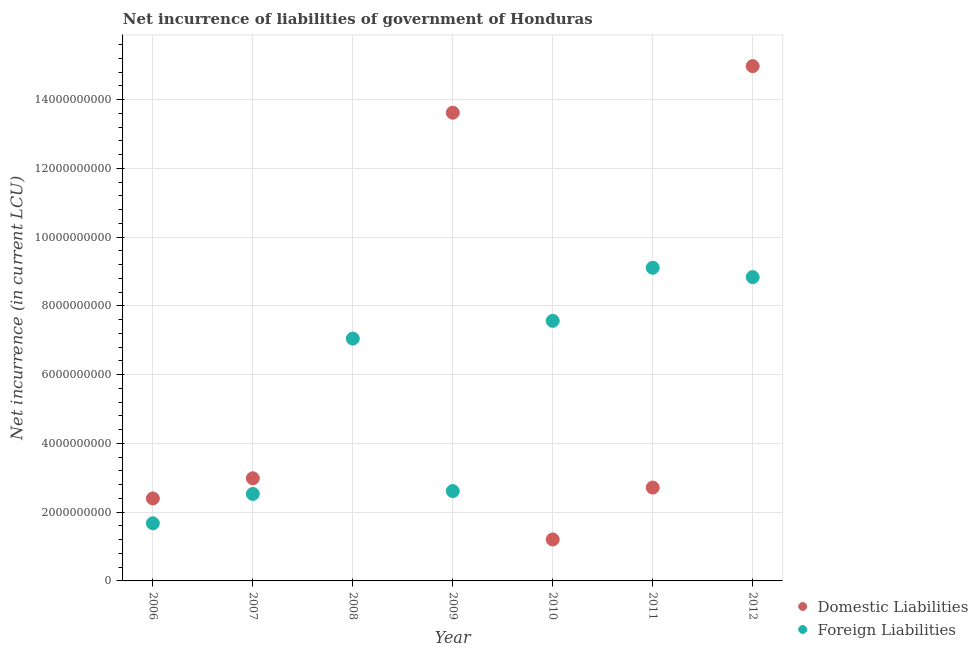How many different coloured dotlines are there?
Your answer should be compact. 2. What is the net incurrence of foreign liabilities in 2007?
Ensure brevity in your answer.  2.53e+09. Across all years, what is the maximum net incurrence of foreign liabilities?
Offer a terse response. 9.11e+09. In which year was the net incurrence of foreign liabilities maximum?
Your response must be concise. 2011. What is the total net incurrence of domestic liabilities in the graph?
Your answer should be compact. 3.79e+1. What is the difference between the net incurrence of foreign liabilities in 2006 and that in 2009?
Your answer should be very brief. -9.38e+08. What is the difference between the net incurrence of foreign liabilities in 2011 and the net incurrence of domestic liabilities in 2007?
Your answer should be compact. 6.12e+09. What is the average net incurrence of foreign liabilities per year?
Provide a short and direct response. 5.63e+09. In the year 2012, what is the difference between the net incurrence of foreign liabilities and net incurrence of domestic liabilities?
Provide a short and direct response. -6.14e+09. What is the ratio of the net incurrence of foreign liabilities in 2007 to that in 2010?
Give a very brief answer. 0.33. Is the net incurrence of domestic liabilities in 2010 less than that in 2011?
Ensure brevity in your answer.  Yes. Is the difference between the net incurrence of domestic liabilities in 2009 and 2012 greater than the difference between the net incurrence of foreign liabilities in 2009 and 2012?
Give a very brief answer. Yes. What is the difference between the highest and the second highest net incurrence of domestic liabilities?
Your answer should be very brief. 1.36e+09. What is the difference between the highest and the lowest net incurrence of foreign liabilities?
Your answer should be very brief. 7.43e+09. Is the sum of the net incurrence of foreign liabilities in 2007 and 2008 greater than the maximum net incurrence of domestic liabilities across all years?
Keep it short and to the point. No. Does the net incurrence of domestic liabilities monotonically increase over the years?
Offer a terse response. No. How many dotlines are there?
Provide a short and direct response. 2. How many years are there in the graph?
Offer a very short reply. 7. What is the difference between two consecutive major ticks on the Y-axis?
Your answer should be very brief. 2.00e+09. Are the values on the major ticks of Y-axis written in scientific E-notation?
Offer a very short reply. No. Does the graph contain grids?
Offer a terse response. Yes. How many legend labels are there?
Give a very brief answer. 2. What is the title of the graph?
Provide a short and direct response. Net incurrence of liabilities of government of Honduras. What is the label or title of the X-axis?
Keep it short and to the point. Year. What is the label or title of the Y-axis?
Provide a succinct answer. Net incurrence (in current LCU). What is the Net incurrence (in current LCU) in Domestic Liabilities in 2006?
Provide a succinct answer. 2.40e+09. What is the Net incurrence (in current LCU) of Foreign Liabilities in 2006?
Give a very brief answer. 1.68e+09. What is the Net incurrence (in current LCU) in Domestic Liabilities in 2007?
Provide a short and direct response. 2.99e+09. What is the Net incurrence (in current LCU) in Foreign Liabilities in 2007?
Offer a very short reply. 2.53e+09. What is the Net incurrence (in current LCU) in Foreign Liabilities in 2008?
Provide a short and direct response. 7.05e+09. What is the Net incurrence (in current LCU) in Domestic Liabilities in 2009?
Provide a short and direct response. 1.36e+1. What is the Net incurrence (in current LCU) of Foreign Liabilities in 2009?
Provide a succinct answer. 2.61e+09. What is the Net incurrence (in current LCU) in Domestic Liabilities in 2010?
Make the answer very short. 1.21e+09. What is the Net incurrence (in current LCU) in Foreign Liabilities in 2010?
Provide a short and direct response. 7.57e+09. What is the Net incurrence (in current LCU) in Domestic Liabilities in 2011?
Provide a short and direct response. 2.72e+09. What is the Net incurrence (in current LCU) in Foreign Liabilities in 2011?
Your response must be concise. 9.11e+09. What is the Net incurrence (in current LCU) in Domestic Liabilities in 2012?
Offer a very short reply. 1.50e+1. What is the Net incurrence (in current LCU) in Foreign Liabilities in 2012?
Your answer should be compact. 8.84e+09. Across all years, what is the maximum Net incurrence (in current LCU) of Domestic Liabilities?
Offer a terse response. 1.50e+1. Across all years, what is the maximum Net incurrence (in current LCU) of Foreign Liabilities?
Your answer should be very brief. 9.11e+09. Across all years, what is the minimum Net incurrence (in current LCU) of Domestic Liabilities?
Offer a very short reply. 0. Across all years, what is the minimum Net incurrence (in current LCU) in Foreign Liabilities?
Your answer should be compact. 1.68e+09. What is the total Net incurrence (in current LCU) in Domestic Liabilities in the graph?
Your response must be concise. 3.79e+1. What is the total Net incurrence (in current LCU) in Foreign Liabilities in the graph?
Provide a short and direct response. 3.94e+1. What is the difference between the Net incurrence (in current LCU) of Domestic Liabilities in 2006 and that in 2007?
Offer a very short reply. -5.87e+08. What is the difference between the Net incurrence (in current LCU) in Foreign Liabilities in 2006 and that in 2007?
Make the answer very short. -8.54e+08. What is the difference between the Net incurrence (in current LCU) in Foreign Liabilities in 2006 and that in 2008?
Keep it short and to the point. -5.37e+09. What is the difference between the Net incurrence (in current LCU) in Domestic Liabilities in 2006 and that in 2009?
Your answer should be compact. -1.12e+1. What is the difference between the Net incurrence (in current LCU) in Foreign Liabilities in 2006 and that in 2009?
Your response must be concise. -9.38e+08. What is the difference between the Net incurrence (in current LCU) of Domestic Liabilities in 2006 and that in 2010?
Keep it short and to the point. 1.19e+09. What is the difference between the Net incurrence (in current LCU) in Foreign Liabilities in 2006 and that in 2010?
Provide a short and direct response. -5.89e+09. What is the difference between the Net incurrence (in current LCU) in Domestic Liabilities in 2006 and that in 2011?
Your answer should be compact. -3.16e+08. What is the difference between the Net incurrence (in current LCU) of Foreign Liabilities in 2006 and that in 2011?
Keep it short and to the point. -7.43e+09. What is the difference between the Net incurrence (in current LCU) of Domestic Liabilities in 2006 and that in 2012?
Your answer should be very brief. -1.26e+1. What is the difference between the Net incurrence (in current LCU) in Foreign Liabilities in 2006 and that in 2012?
Give a very brief answer. -7.16e+09. What is the difference between the Net incurrence (in current LCU) of Foreign Liabilities in 2007 and that in 2008?
Your answer should be compact. -4.52e+09. What is the difference between the Net incurrence (in current LCU) of Domestic Liabilities in 2007 and that in 2009?
Offer a terse response. -1.06e+1. What is the difference between the Net incurrence (in current LCU) of Foreign Liabilities in 2007 and that in 2009?
Offer a terse response. -8.36e+07. What is the difference between the Net incurrence (in current LCU) of Domestic Liabilities in 2007 and that in 2010?
Ensure brevity in your answer.  1.78e+09. What is the difference between the Net incurrence (in current LCU) in Foreign Liabilities in 2007 and that in 2010?
Give a very brief answer. -5.04e+09. What is the difference between the Net incurrence (in current LCU) of Domestic Liabilities in 2007 and that in 2011?
Ensure brevity in your answer.  2.71e+08. What is the difference between the Net incurrence (in current LCU) of Foreign Liabilities in 2007 and that in 2011?
Offer a very short reply. -6.58e+09. What is the difference between the Net incurrence (in current LCU) of Domestic Liabilities in 2007 and that in 2012?
Offer a terse response. -1.20e+1. What is the difference between the Net incurrence (in current LCU) of Foreign Liabilities in 2007 and that in 2012?
Your response must be concise. -6.31e+09. What is the difference between the Net incurrence (in current LCU) of Foreign Liabilities in 2008 and that in 2009?
Give a very brief answer. 4.44e+09. What is the difference between the Net incurrence (in current LCU) of Foreign Liabilities in 2008 and that in 2010?
Ensure brevity in your answer.  -5.16e+08. What is the difference between the Net incurrence (in current LCU) of Foreign Liabilities in 2008 and that in 2011?
Keep it short and to the point. -2.06e+09. What is the difference between the Net incurrence (in current LCU) of Foreign Liabilities in 2008 and that in 2012?
Your answer should be very brief. -1.79e+09. What is the difference between the Net incurrence (in current LCU) of Domestic Liabilities in 2009 and that in 2010?
Offer a very short reply. 1.24e+1. What is the difference between the Net incurrence (in current LCU) in Foreign Liabilities in 2009 and that in 2010?
Make the answer very short. -4.95e+09. What is the difference between the Net incurrence (in current LCU) in Domestic Liabilities in 2009 and that in 2011?
Your answer should be very brief. 1.09e+1. What is the difference between the Net incurrence (in current LCU) of Foreign Liabilities in 2009 and that in 2011?
Your answer should be compact. -6.50e+09. What is the difference between the Net incurrence (in current LCU) in Domestic Liabilities in 2009 and that in 2012?
Offer a terse response. -1.36e+09. What is the difference between the Net incurrence (in current LCU) in Foreign Liabilities in 2009 and that in 2012?
Make the answer very short. -6.22e+09. What is the difference between the Net incurrence (in current LCU) of Domestic Liabilities in 2010 and that in 2011?
Your answer should be very brief. -1.51e+09. What is the difference between the Net incurrence (in current LCU) of Foreign Liabilities in 2010 and that in 2011?
Your response must be concise. -1.55e+09. What is the difference between the Net incurrence (in current LCU) in Domestic Liabilities in 2010 and that in 2012?
Your answer should be very brief. -1.38e+1. What is the difference between the Net incurrence (in current LCU) in Foreign Liabilities in 2010 and that in 2012?
Your answer should be very brief. -1.27e+09. What is the difference between the Net incurrence (in current LCU) of Domestic Liabilities in 2011 and that in 2012?
Ensure brevity in your answer.  -1.23e+1. What is the difference between the Net incurrence (in current LCU) of Foreign Liabilities in 2011 and that in 2012?
Offer a very short reply. 2.72e+08. What is the difference between the Net incurrence (in current LCU) in Domestic Liabilities in 2006 and the Net incurrence (in current LCU) in Foreign Liabilities in 2007?
Your answer should be compact. -1.31e+08. What is the difference between the Net incurrence (in current LCU) of Domestic Liabilities in 2006 and the Net incurrence (in current LCU) of Foreign Liabilities in 2008?
Provide a short and direct response. -4.65e+09. What is the difference between the Net incurrence (in current LCU) in Domestic Liabilities in 2006 and the Net incurrence (in current LCU) in Foreign Liabilities in 2009?
Ensure brevity in your answer.  -2.15e+08. What is the difference between the Net incurrence (in current LCU) of Domestic Liabilities in 2006 and the Net incurrence (in current LCU) of Foreign Liabilities in 2010?
Keep it short and to the point. -5.17e+09. What is the difference between the Net incurrence (in current LCU) of Domestic Liabilities in 2006 and the Net incurrence (in current LCU) of Foreign Liabilities in 2011?
Ensure brevity in your answer.  -6.71e+09. What is the difference between the Net incurrence (in current LCU) of Domestic Liabilities in 2006 and the Net incurrence (in current LCU) of Foreign Liabilities in 2012?
Offer a very short reply. -6.44e+09. What is the difference between the Net incurrence (in current LCU) in Domestic Liabilities in 2007 and the Net incurrence (in current LCU) in Foreign Liabilities in 2008?
Your response must be concise. -4.06e+09. What is the difference between the Net incurrence (in current LCU) in Domestic Liabilities in 2007 and the Net incurrence (in current LCU) in Foreign Liabilities in 2009?
Provide a succinct answer. 3.72e+08. What is the difference between the Net incurrence (in current LCU) in Domestic Liabilities in 2007 and the Net incurrence (in current LCU) in Foreign Liabilities in 2010?
Give a very brief answer. -4.58e+09. What is the difference between the Net incurrence (in current LCU) of Domestic Liabilities in 2007 and the Net incurrence (in current LCU) of Foreign Liabilities in 2011?
Your answer should be very brief. -6.12e+09. What is the difference between the Net incurrence (in current LCU) of Domestic Liabilities in 2007 and the Net incurrence (in current LCU) of Foreign Liabilities in 2012?
Your answer should be very brief. -5.85e+09. What is the difference between the Net incurrence (in current LCU) of Domestic Liabilities in 2009 and the Net incurrence (in current LCU) of Foreign Liabilities in 2010?
Offer a very short reply. 6.06e+09. What is the difference between the Net incurrence (in current LCU) in Domestic Liabilities in 2009 and the Net incurrence (in current LCU) in Foreign Liabilities in 2011?
Your answer should be very brief. 4.51e+09. What is the difference between the Net incurrence (in current LCU) of Domestic Liabilities in 2009 and the Net incurrence (in current LCU) of Foreign Liabilities in 2012?
Your response must be concise. 4.78e+09. What is the difference between the Net incurrence (in current LCU) in Domestic Liabilities in 2010 and the Net incurrence (in current LCU) in Foreign Liabilities in 2011?
Provide a succinct answer. -7.91e+09. What is the difference between the Net incurrence (in current LCU) in Domestic Liabilities in 2010 and the Net incurrence (in current LCU) in Foreign Liabilities in 2012?
Offer a terse response. -7.63e+09. What is the difference between the Net incurrence (in current LCU) of Domestic Liabilities in 2011 and the Net incurrence (in current LCU) of Foreign Liabilities in 2012?
Provide a succinct answer. -6.12e+09. What is the average Net incurrence (in current LCU) of Domestic Liabilities per year?
Keep it short and to the point. 5.42e+09. What is the average Net incurrence (in current LCU) of Foreign Liabilities per year?
Keep it short and to the point. 5.63e+09. In the year 2006, what is the difference between the Net incurrence (in current LCU) in Domestic Liabilities and Net incurrence (in current LCU) in Foreign Liabilities?
Offer a very short reply. 7.23e+08. In the year 2007, what is the difference between the Net incurrence (in current LCU) of Domestic Liabilities and Net incurrence (in current LCU) of Foreign Liabilities?
Your answer should be compact. 4.56e+08. In the year 2009, what is the difference between the Net incurrence (in current LCU) of Domestic Liabilities and Net incurrence (in current LCU) of Foreign Liabilities?
Offer a terse response. 1.10e+1. In the year 2010, what is the difference between the Net incurrence (in current LCU) in Domestic Liabilities and Net incurrence (in current LCU) in Foreign Liabilities?
Ensure brevity in your answer.  -6.36e+09. In the year 2011, what is the difference between the Net incurrence (in current LCU) of Domestic Liabilities and Net incurrence (in current LCU) of Foreign Liabilities?
Ensure brevity in your answer.  -6.40e+09. In the year 2012, what is the difference between the Net incurrence (in current LCU) in Domestic Liabilities and Net incurrence (in current LCU) in Foreign Liabilities?
Give a very brief answer. 6.14e+09. What is the ratio of the Net incurrence (in current LCU) of Domestic Liabilities in 2006 to that in 2007?
Your response must be concise. 0.8. What is the ratio of the Net incurrence (in current LCU) in Foreign Liabilities in 2006 to that in 2007?
Your response must be concise. 0.66. What is the ratio of the Net incurrence (in current LCU) in Foreign Liabilities in 2006 to that in 2008?
Your answer should be very brief. 0.24. What is the ratio of the Net incurrence (in current LCU) of Domestic Liabilities in 2006 to that in 2009?
Provide a short and direct response. 0.18. What is the ratio of the Net incurrence (in current LCU) of Foreign Liabilities in 2006 to that in 2009?
Provide a short and direct response. 0.64. What is the ratio of the Net incurrence (in current LCU) in Domestic Liabilities in 2006 to that in 2010?
Offer a very short reply. 1.99. What is the ratio of the Net incurrence (in current LCU) in Foreign Liabilities in 2006 to that in 2010?
Offer a very short reply. 0.22. What is the ratio of the Net incurrence (in current LCU) of Domestic Liabilities in 2006 to that in 2011?
Give a very brief answer. 0.88. What is the ratio of the Net incurrence (in current LCU) of Foreign Liabilities in 2006 to that in 2011?
Provide a succinct answer. 0.18. What is the ratio of the Net incurrence (in current LCU) in Domestic Liabilities in 2006 to that in 2012?
Give a very brief answer. 0.16. What is the ratio of the Net incurrence (in current LCU) of Foreign Liabilities in 2006 to that in 2012?
Offer a very short reply. 0.19. What is the ratio of the Net incurrence (in current LCU) of Foreign Liabilities in 2007 to that in 2008?
Offer a very short reply. 0.36. What is the ratio of the Net incurrence (in current LCU) of Domestic Liabilities in 2007 to that in 2009?
Your response must be concise. 0.22. What is the ratio of the Net incurrence (in current LCU) in Domestic Liabilities in 2007 to that in 2010?
Keep it short and to the point. 2.48. What is the ratio of the Net incurrence (in current LCU) in Foreign Liabilities in 2007 to that in 2010?
Your answer should be very brief. 0.33. What is the ratio of the Net incurrence (in current LCU) of Domestic Liabilities in 2007 to that in 2011?
Your answer should be compact. 1.1. What is the ratio of the Net incurrence (in current LCU) in Foreign Liabilities in 2007 to that in 2011?
Make the answer very short. 0.28. What is the ratio of the Net incurrence (in current LCU) of Domestic Liabilities in 2007 to that in 2012?
Give a very brief answer. 0.2. What is the ratio of the Net incurrence (in current LCU) in Foreign Liabilities in 2007 to that in 2012?
Give a very brief answer. 0.29. What is the ratio of the Net incurrence (in current LCU) in Foreign Liabilities in 2008 to that in 2009?
Provide a succinct answer. 2.7. What is the ratio of the Net incurrence (in current LCU) of Foreign Liabilities in 2008 to that in 2010?
Offer a very short reply. 0.93. What is the ratio of the Net incurrence (in current LCU) in Foreign Liabilities in 2008 to that in 2011?
Give a very brief answer. 0.77. What is the ratio of the Net incurrence (in current LCU) of Foreign Liabilities in 2008 to that in 2012?
Provide a short and direct response. 0.8. What is the ratio of the Net incurrence (in current LCU) of Domestic Liabilities in 2009 to that in 2010?
Your answer should be very brief. 11.3. What is the ratio of the Net incurrence (in current LCU) in Foreign Liabilities in 2009 to that in 2010?
Offer a very short reply. 0.35. What is the ratio of the Net incurrence (in current LCU) of Domestic Liabilities in 2009 to that in 2011?
Provide a succinct answer. 5.02. What is the ratio of the Net incurrence (in current LCU) of Foreign Liabilities in 2009 to that in 2011?
Keep it short and to the point. 0.29. What is the ratio of the Net incurrence (in current LCU) in Domestic Liabilities in 2009 to that in 2012?
Keep it short and to the point. 0.91. What is the ratio of the Net incurrence (in current LCU) in Foreign Liabilities in 2009 to that in 2012?
Offer a terse response. 0.3. What is the ratio of the Net incurrence (in current LCU) of Domestic Liabilities in 2010 to that in 2011?
Ensure brevity in your answer.  0.44. What is the ratio of the Net incurrence (in current LCU) in Foreign Liabilities in 2010 to that in 2011?
Provide a short and direct response. 0.83. What is the ratio of the Net incurrence (in current LCU) of Domestic Liabilities in 2010 to that in 2012?
Make the answer very short. 0.08. What is the ratio of the Net incurrence (in current LCU) in Foreign Liabilities in 2010 to that in 2012?
Your answer should be very brief. 0.86. What is the ratio of the Net incurrence (in current LCU) of Domestic Liabilities in 2011 to that in 2012?
Give a very brief answer. 0.18. What is the ratio of the Net incurrence (in current LCU) in Foreign Liabilities in 2011 to that in 2012?
Provide a succinct answer. 1.03. What is the difference between the highest and the second highest Net incurrence (in current LCU) in Domestic Liabilities?
Ensure brevity in your answer.  1.36e+09. What is the difference between the highest and the second highest Net incurrence (in current LCU) of Foreign Liabilities?
Give a very brief answer. 2.72e+08. What is the difference between the highest and the lowest Net incurrence (in current LCU) of Domestic Liabilities?
Provide a succinct answer. 1.50e+1. What is the difference between the highest and the lowest Net incurrence (in current LCU) in Foreign Liabilities?
Give a very brief answer. 7.43e+09. 